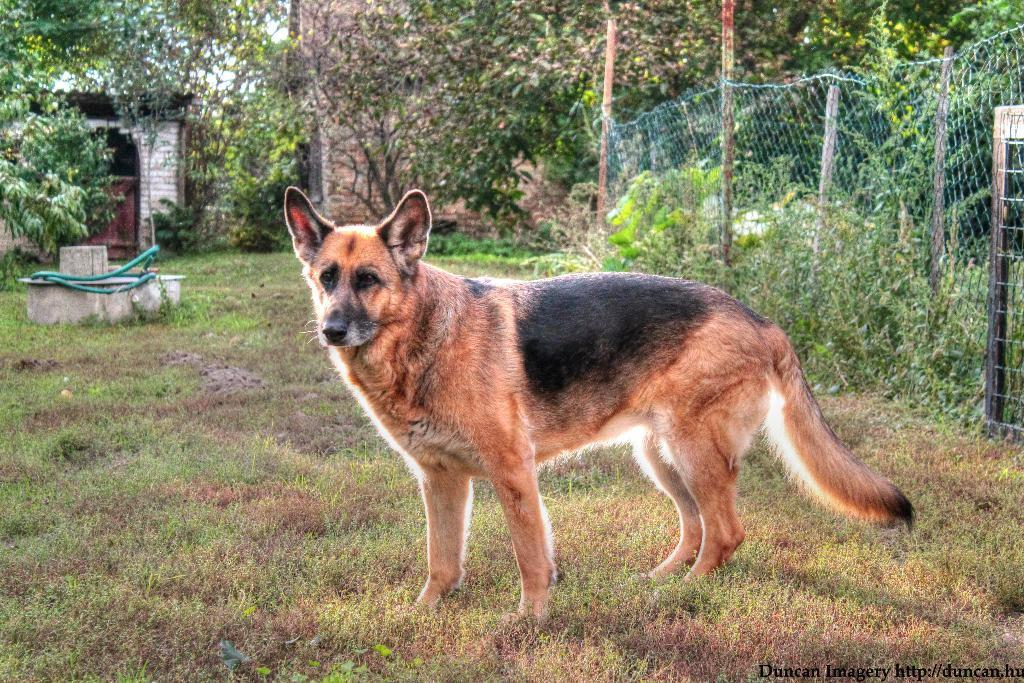What is the main subject in the center of the image? There is a dog in the center of the image. What is the dog standing on? The dog is on the grass. What can be seen in the background of the image? There are trees and buildings in the background of the image. What is located on the right side of the image? There is a fencing on the right side of the image. What type of oil can be seen leaking from the top of the industry building in the image? There is no oil or industry building present in the image; it features a dog on the grass with trees and buildings in the background. 